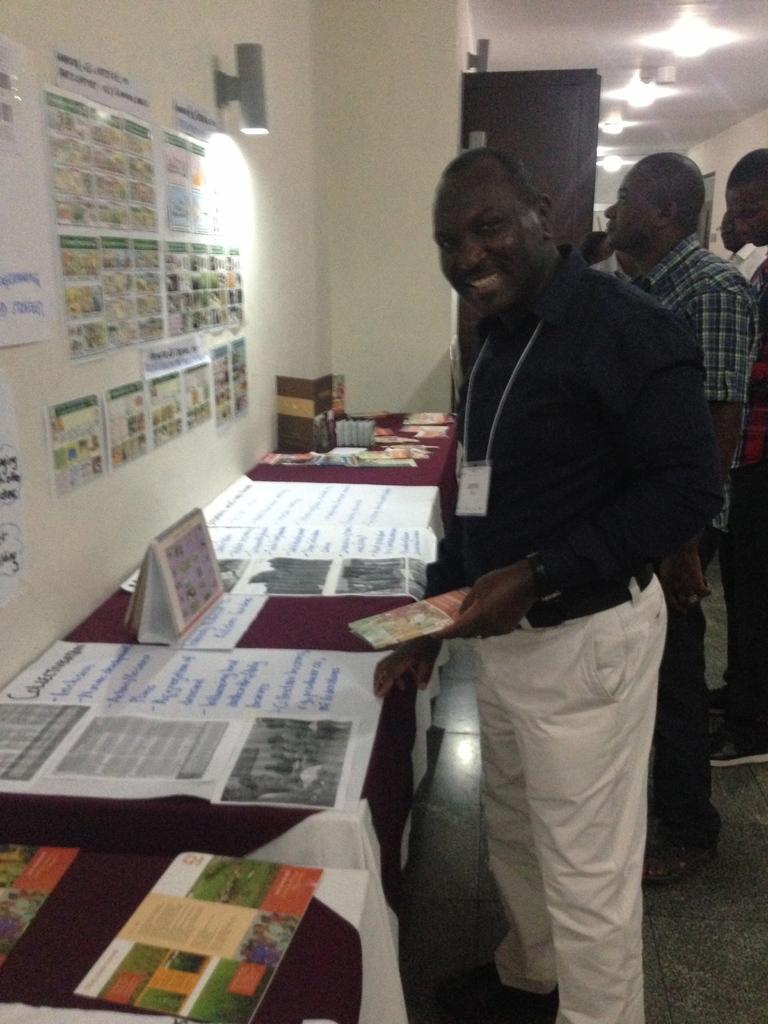Please provide a concise description of this image. In the image we can see there are people who are standing and on table there are charts and booklets and on the wall there are papers which are sticked. 